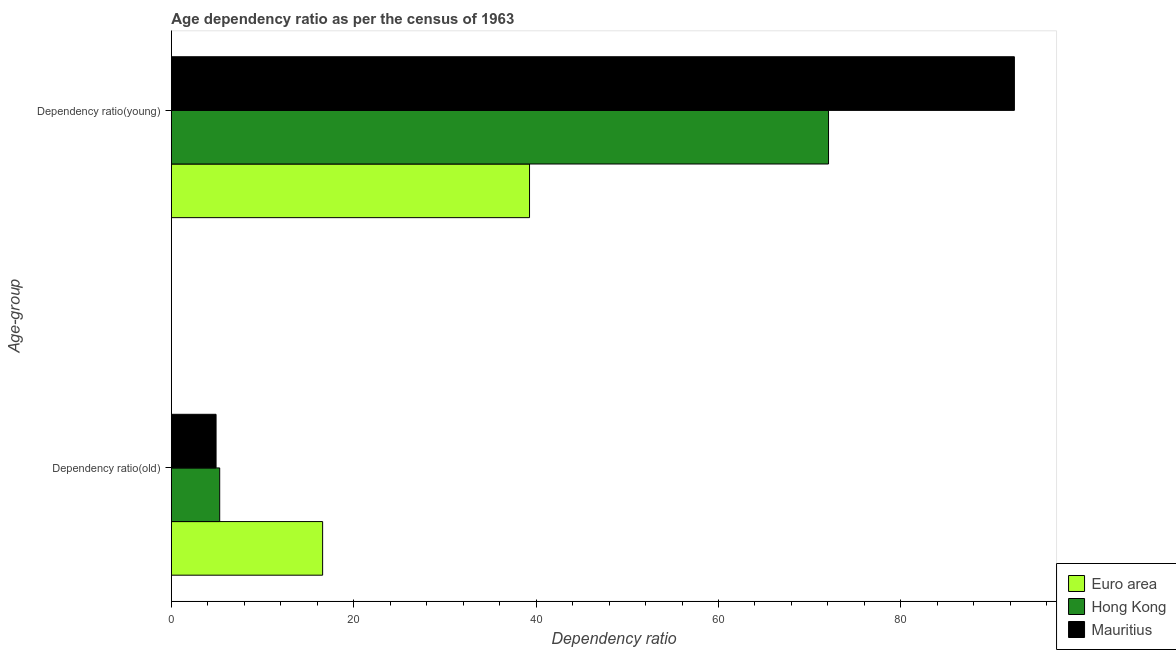How many groups of bars are there?
Make the answer very short. 2. Are the number of bars per tick equal to the number of legend labels?
Keep it short and to the point. Yes. Are the number of bars on each tick of the Y-axis equal?
Ensure brevity in your answer.  Yes. How many bars are there on the 1st tick from the bottom?
Your response must be concise. 3. What is the label of the 1st group of bars from the top?
Ensure brevity in your answer.  Dependency ratio(young). What is the age dependency ratio(young) in Mauritius?
Provide a short and direct response. 92.45. Across all countries, what is the maximum age dependency ratio(old)?
Offer a very short reply. 16.59. Across all countries, what is the minimum age dependency ratio(old)?
Provide a succinct answer. 4.9. In which country was the age dependency ratio(young) maximum?
Ensure brevity in your answer.  Mauritius. In which country was the age dependency ratio(young) minimum?
Ensure brevity in your answer.  Euro area. What is the total age dependency ratio(young) in the graph?
Provide a succinct answer. 203.79. What is the difference between the age dependency ratio(old) in Euro area and that in Mauritius?
Offer a terse response. 11.69. What is the difference between the age dependency ratio(old) in Mauritius and the age dependency ratio(young) in Hong Kong?
Provide a short and direct response. -67.16. What is the average age dependency ratio(old) per country?
Provide a short and direct response. 8.93. What is the difference between the age dependency ratio(young) and age dependency ratio(old) in Mauritius?
Provide a succinct answer. 87.55. In how many countries, is the age dependency ratio(old) greater than 68 ?
Your answer should be compact. 0. What is the ratio of the age dependency ratio(old) in Euro area to that in Mauritius?
Your answer should be compact. 3.38. In how many countries, is the age dependency ratio(young) greater than the average age dependency ratio(young) taken over all countries?
Give a very brief answer. 2. Are all the bars in the graph horizontal?
Your answer should be very brief. Yes. How many countries are there in the graph?
Give a very brief answer. 3. Does the graph contain any zero values?
Provide a succinct answer. No. Where does the legend appear in the graph?
Provide a short and direct response. Bottom right. What is the title of the graph?
Offer a terse response. Age dependency ratio as per the census of 1963. Does "Botswana" appear as one of the legend labels in the graph?
Give a very brief answer. No. What is the label or title of the X-axis?
Give a very brief answer. Dependency ratio. What is the label or title of the Y-axis?
Give a very brief answer. Age-group. What is the Dependency ratio of Euro area in Dependency ratio(old)?
Your response must be concise. 16.59. What is the Dependency ratio in Hong Kong in Dependency ratio(old)?
Your answer should be compact. 5.3. What is the Dependency ratio in Mauritius in Dependency ratio(old)?
Offer a terse response. 4.9. What is the Dependency ratio of Euro area in Dependency ratio(young)?
Make the answer very short. 39.28. What is the Dependency ratio of Hong Kong in Dependency ratio(young)?
Give a very brief answer. 72.07. What is the Dependency ratio of Mauritius in Dependency ratio(young)?
Provide a succinct answer. 92.45. Across all Age-group, what is the maximum Dependency ratio in Euro area?
Your response must be concise. 39.28. Across all Age-group, what is the maximum Dependency ratio in Hong Kong?
Keep it short and to the point. 72.07. Across all Age-group, what is the maximum Dependency ratio in Mauritius?
Provide a succinct answer. 92.45. Across all Age-group, what is the minimum Dependency ratio in Euro area?
Provide a short and direct response. 16.59. Across all Age-group, what is the minimum Dependency ratio of Hong Kong?
Give a very brief answer. 5.3. Across all Age-group, what is the minimum Dependency ratio of Mauritius?
Offer a terse response. 4.9. What is the total Dependency ratio of Euro area in the graph?
Your response must be concise. 55.86. What is the total Dependency ratio in Hong Kong in the graph?
Ensure brevity in your answer.  77.36. What is the total Dependency ratio of Mauritius in the graph?
Your answer should be compact. 97.35. What is the difference between the Dependency ratio of Euro area in Dependency ratio(old) and that in Dependency ratio(young)?
Provide a short and direct response. -22.69. What is the difference between the Dependency ratio of Hong Kong in Dependency ratio(old) and that in Dependency ratio(young)?
Your response must be concise. -66.77. What is the difference between the Dependency ratio of Mauritius in Dependency ratio(old) and that in Dependency ratio(young)?
Offer a terse response. -87.55. What is the difference between the Dependency ratio in Euro area in Dependency ratio(old) and the Dependency ratio in Hong Kong in Dependency ratio(young)?
Provide a succinct answer. -55.48. What is the difference between the Dependency ratio of Euro area in Dependency ratio(old) and the Dependency ratio of Mauritius in Dependency ratio(young)?
Your response must be concise. -75.86. What is the difference between the Dependency ratio of Hong Kong in Dependency ratio(old) and the Dependency ratio of Mauritius in Dependency ratio(young)?
Your answer should be compact. -87.15. What is the average Dependency ratio of Euro area per Age-group?
Make the answer very short. 27.93. What is the average Dependency ratio in Hong Kong per Age-group?
Offer a very short reply. 38.68. What is the average Dependency ratio of Mauritius per Age-group?
Ensure brevity in your answer.  48.67. What is the difference between the Dependency ratio of Euro area and Dependency ratio of Hong Kong in Dependency ratio(old)?
Your answer should be compact. 11.29. What is the difference between the Dependency ratio in Euro area and Dependency ratio in Mauritius in Dependency ratio(old)?
Your answer should be very brief. 11.69. What is the difference between the Dependency ratio of Hong Kong and Dependency ratio of Mauritius in Dependency ratio(old)?
Provide a short and direct response. 0.4. What is the difference between the Dependency ratio in Euro area and Dependency ratio in Hong Kong in Dependency ratio(young)?
Your response must be concise. -32.79. What is the difference between the Dependency ratio of Euro area and Dependency ratio of Mauritius in Dependency ratio(young)?
Ensure brevity in your answer.  -53.17. What is the difference between the Dependency ratio in Hong Kong and Dependency ratio in Mauritius in Dependency ratio(young)?
Give a very brief answer. -20.38. What is the ratio of the Dependency ratio in Euro area in Dependency ratio(old) to that in Dependency ratio(young)?
Your answer should be very brief. 0.42. What is the ratio of the Dependency ratio in Hong Kong in Dependency ratio(old) to that in Dependency ratio(young)?
Offer a very short reply. 0.07. What is the ratio of the Dependency ratio in Mauritius in Dependency ratio(old) to that in Dependency ratio(young)?
Give a very brief answer. 0.05. What is the difference between the highest and the second highest Dependency ratio of Euro area?
Ensure brevity in your answer.  22.69. What is the difference between the highest and the second highest Dependency ratio of Hong Kong?
Make the answer very short. 66.77. What is the difference between the highest and the second highest Dependency ratio of Mauritius?
Keep it short and to the point. 87.55. What is the difference between the highest and the lowest Dependency ratio in Euro area?
Ensure brevity in your answer.  22.69. What is the difference between the highest and the lowest Dependency ratio in Hong Kong?
Keep it short and to the point. 66.77. What is the difference between the highest and the lowest Dependency ratio in Mauritius?
Provide a short and direct response. 87.55. 